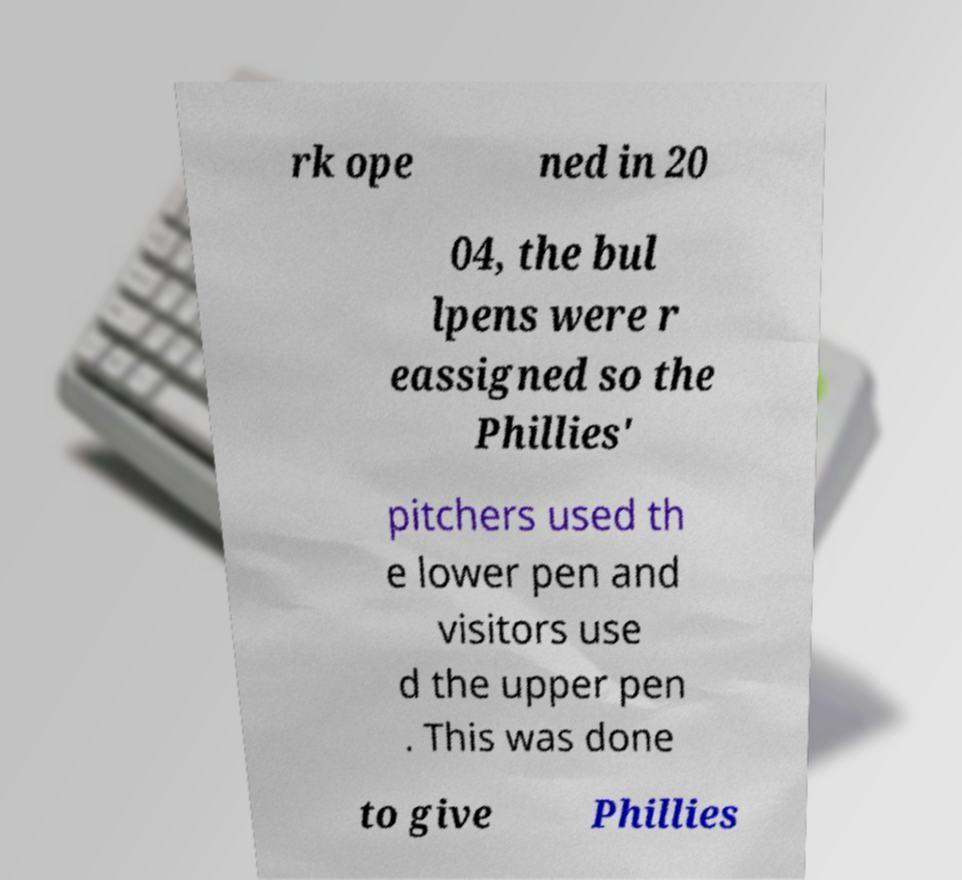For documentation purposes, I need the text within this image transcribed. Could you provide that? rk ope ned in 20 04, the bul lpens were r eassigned so the Phillies' pitchers used th e lower pen and visitors use d the upper pen . This was done to give Phillies 